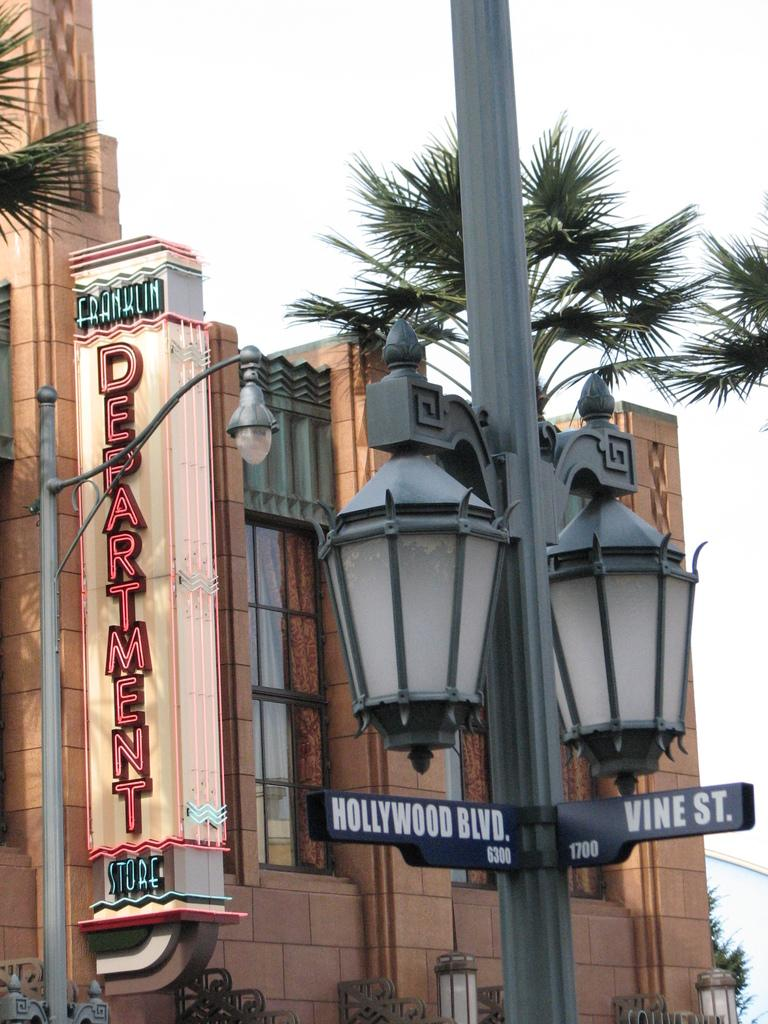<image>
Give a short and clear explanation of the subsequent image. Double streetlamp at the intersection of Hollywood Blvd. and Vine St. in front of the Franklin Department Store. 